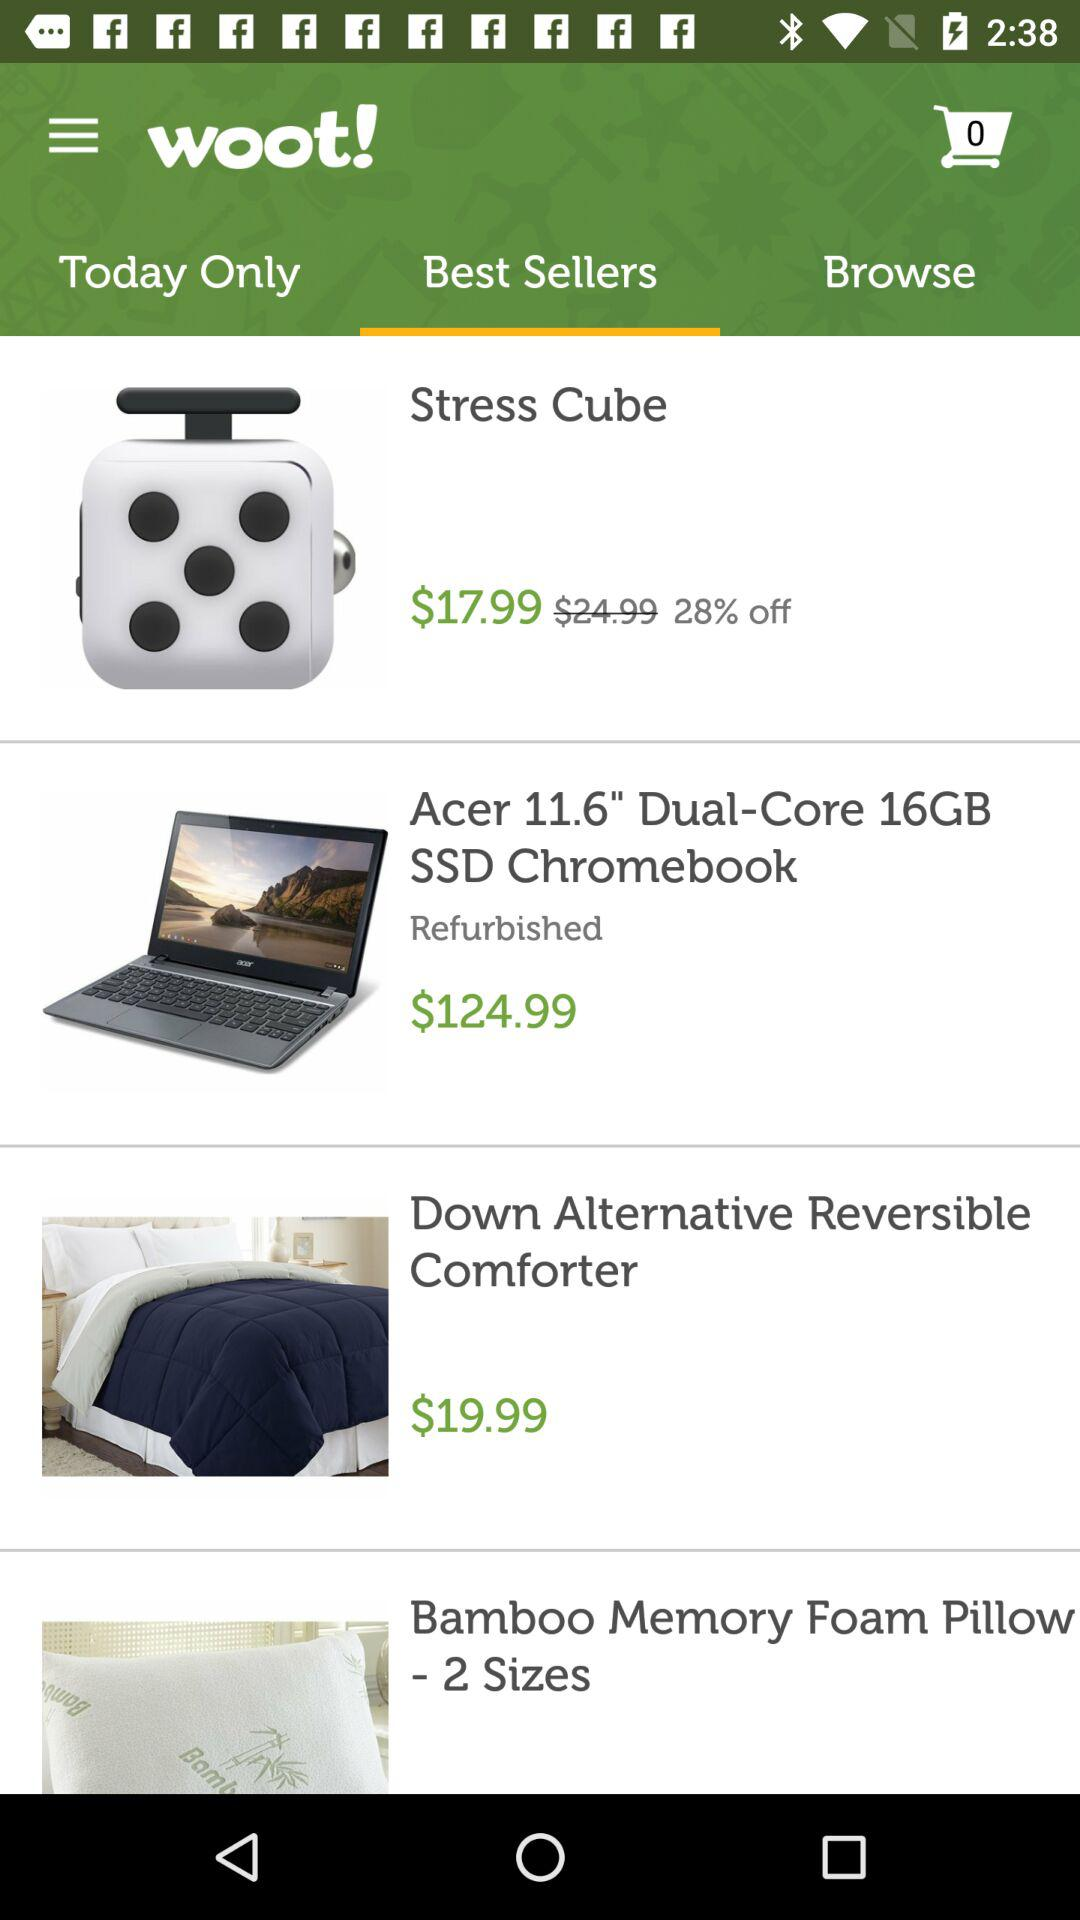Which tab is selected? The selected tab is "Best Sellers". 